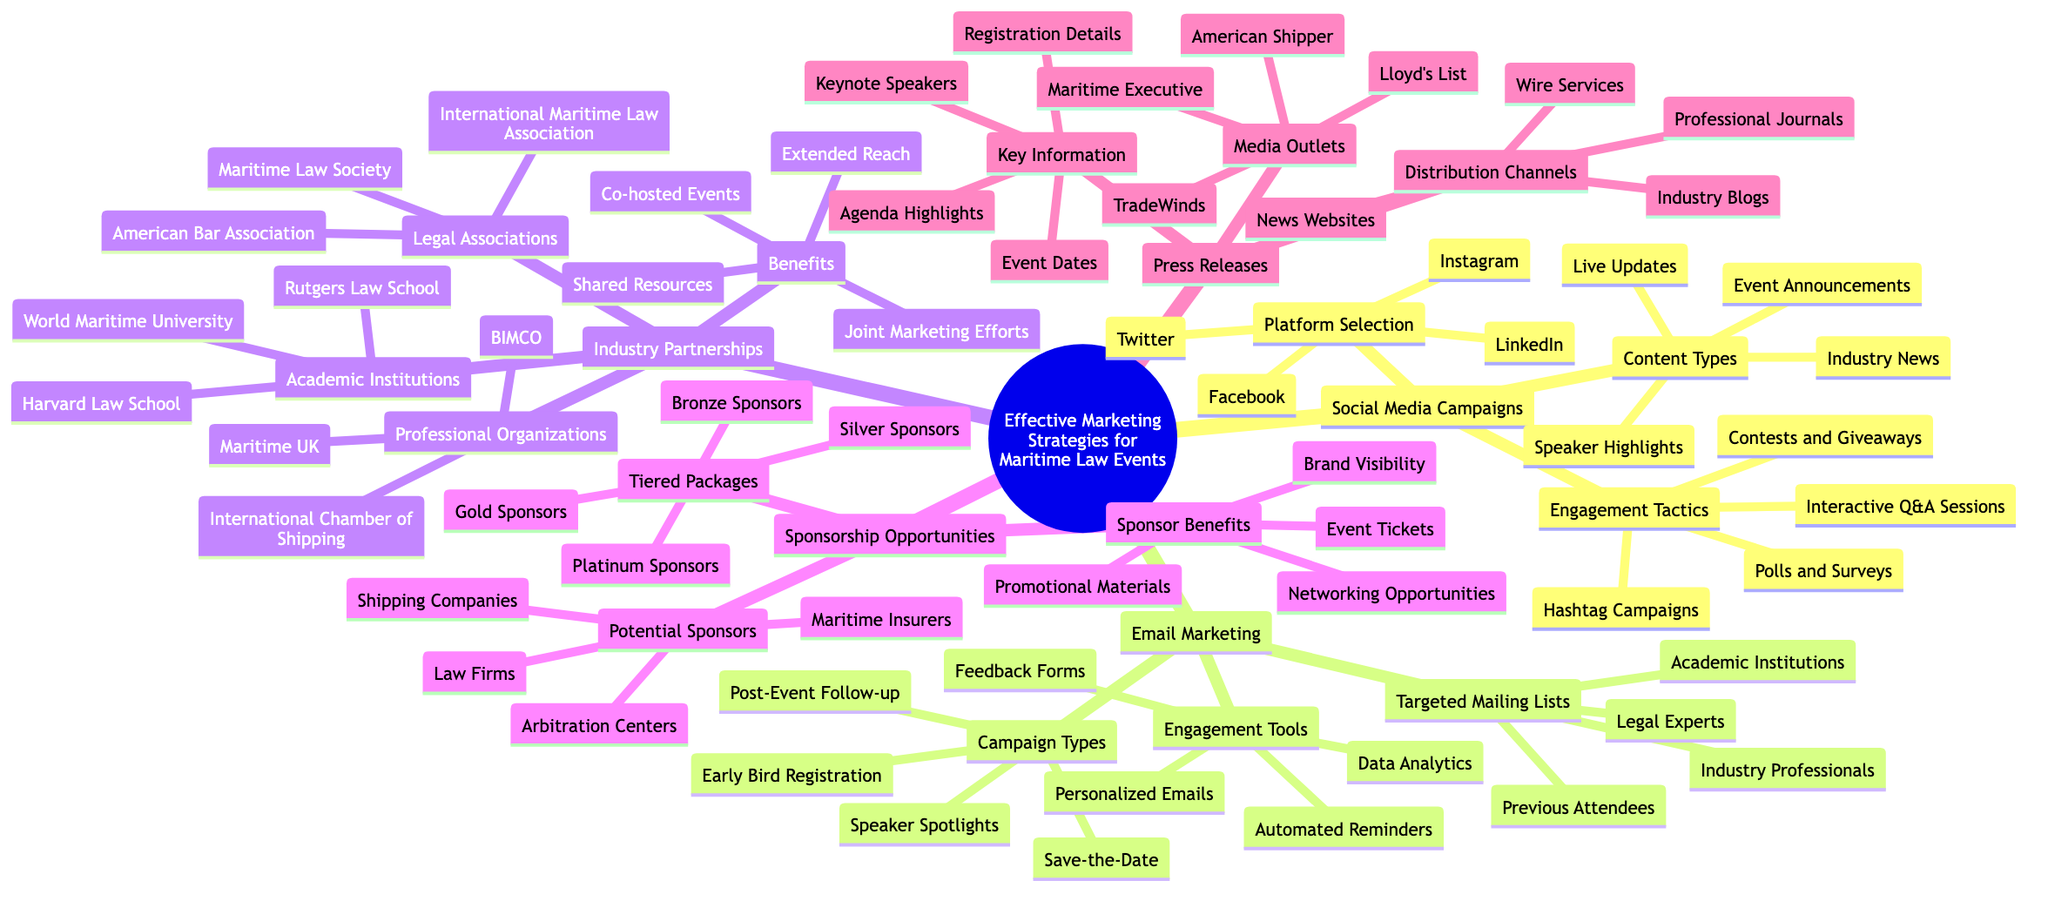What are the engagement tactics listed under social media campaigns? The diagram shows four engagement tactics beneath the "Social Media Campaigns" node: Hashtag Campaigns, Polls and Surveys, Interactive Q&A Sessions, and Contests and Giveaways.
Answer: Hashtag Campaigns, Polls and Surveys, Interactive Q&A Sessions, Contests and Giveaways How many key information items are listed under press releases? In the "Press Releases" section, there are four key information items identified: Event Dates, Keynote Speakers, Agenda Highlights, and Registration Details. Therefore, there are a total of four items.
Answer: 4 What is one benefit of industry partnerships? The diagram outlines several benefits of Industry Partnerships, including Co-hosted Events, Joint Marketing Efforts, Extended Reach, and Shared Resources. One example of such a benefit is Co-hosted Events.
Answer: Co-hosted Events Which platform is NOT mentioned in the social media campaign's platform selection? The platforms selected in the diagram for social media campaigns are LinkedIn, Twitter, Facebook, and Instagram. Hence, platforms like Reddit or TikTok are not mentioned.
Answer: Reddit (or TikTok) How many types of email marketing campaigns are outlined? The section on Email Marketing lists four types of campaigns: Save-the-Date, Early Bird Registration, Speaker Spotlights, and Post-Event Follow-up. Therefore, there are four campaign types.
Answer: 4 What tier package offers the highest sponsorship level? The Sponsorship Opportunities section lists tiered packages including Platinum Sponsors, Gold Sponsors, Silver Sponsors, and Bronze Sponsors. The package that offers the highest sponsorship level is Platinum Sponsors.
Answer: Platinum Sponsors Which academic institution is listed under industry partnerships? The Industry Partnerships section details academic institutions, among which are World Maritime University, Rutgers Law School, and Harvard Law School. An example of an academic institution listed is Harvard Law School.
Answer: Harvard Law School What type of organizations are included in the professional organizations of industry partnerships? Under the Industry Partnerships, there are several professional organizations listed, including the International Chamber of Shipping, BIMCO, and Maritime UK. One example is BIMCO.
Answer: BIMCO 